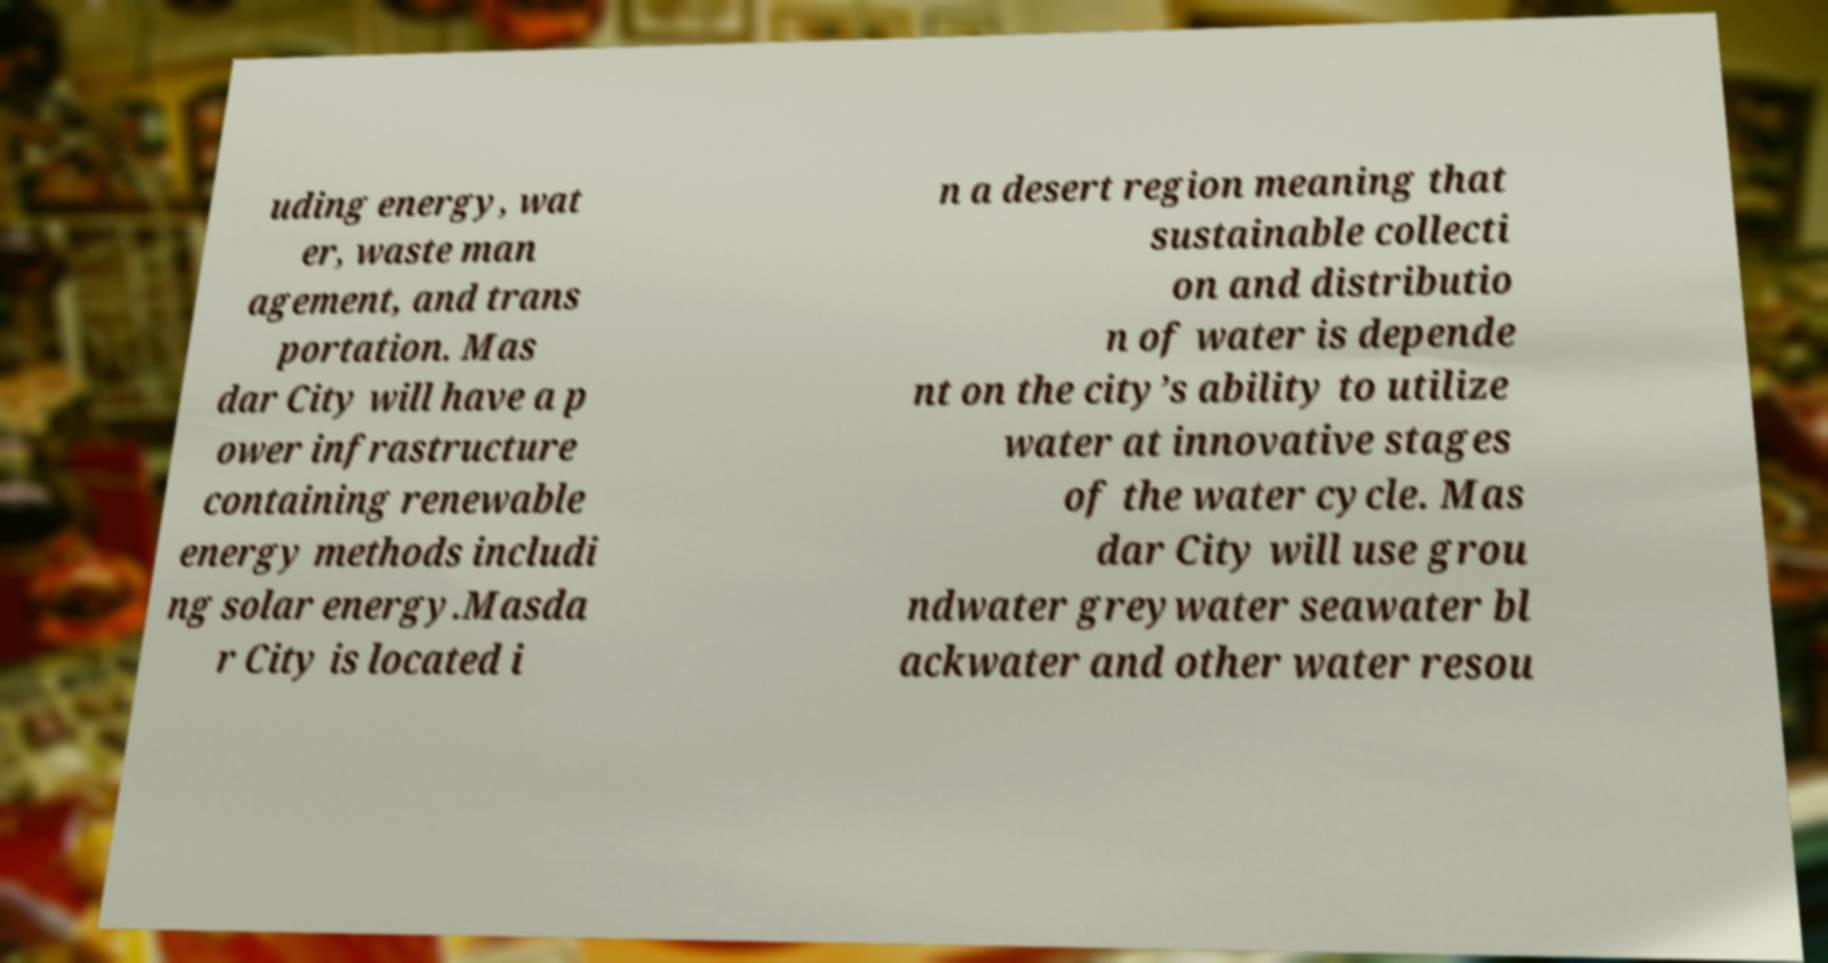Could you assist in decoding the text presented in this image and type it out clearly? uding energy, wat er, waste man agement, and trans portation. Mas dar City will have a p ower infrastructure containing renewable energy methods includi ng solar energy.Masda r City is located i n a desert region meaning that sustainable collecti on and distributio n of water is depende nt on the city’s ability to utilize water at innovative stages of the water cycle. Mas dar City will use grou ndwater greywater seawater bl ackwater and other water resou 